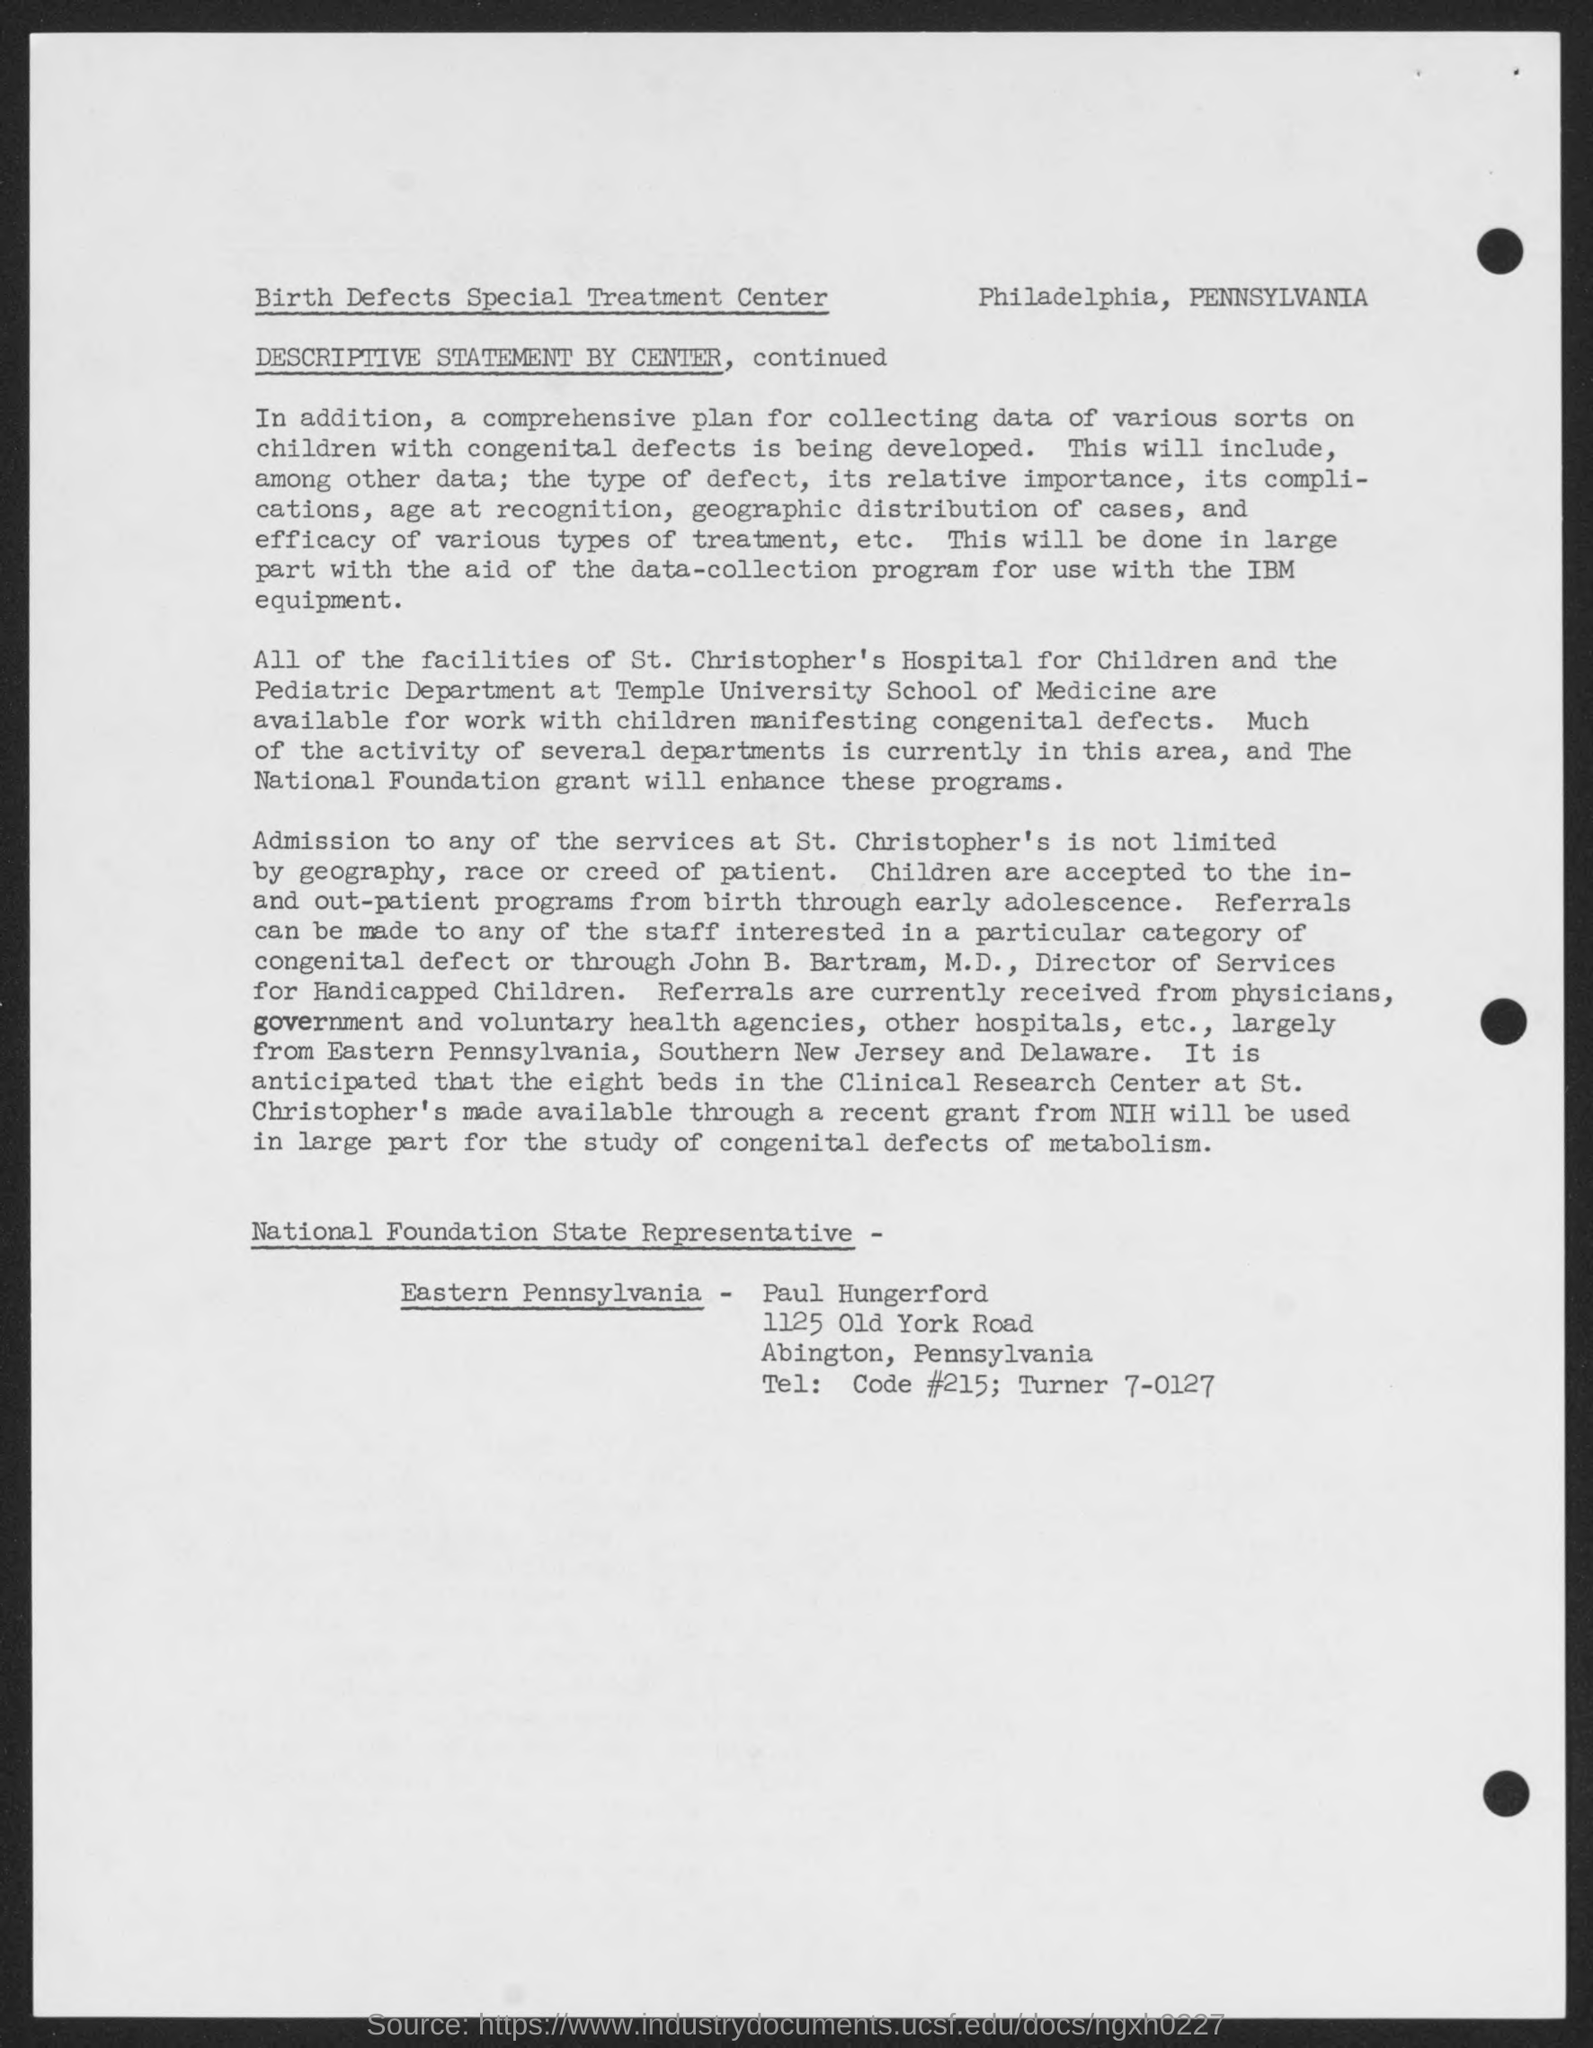Admission to which hospital is not limited to geogarphy, race or creed of the patient?
Give a very brief answer. St. Christopher's. 